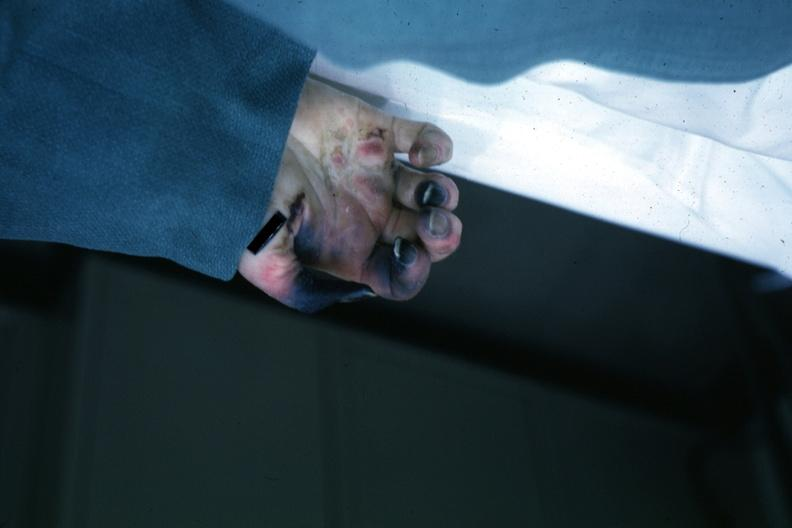s hand present?
Answer the question using a single word or phrase. Yes 